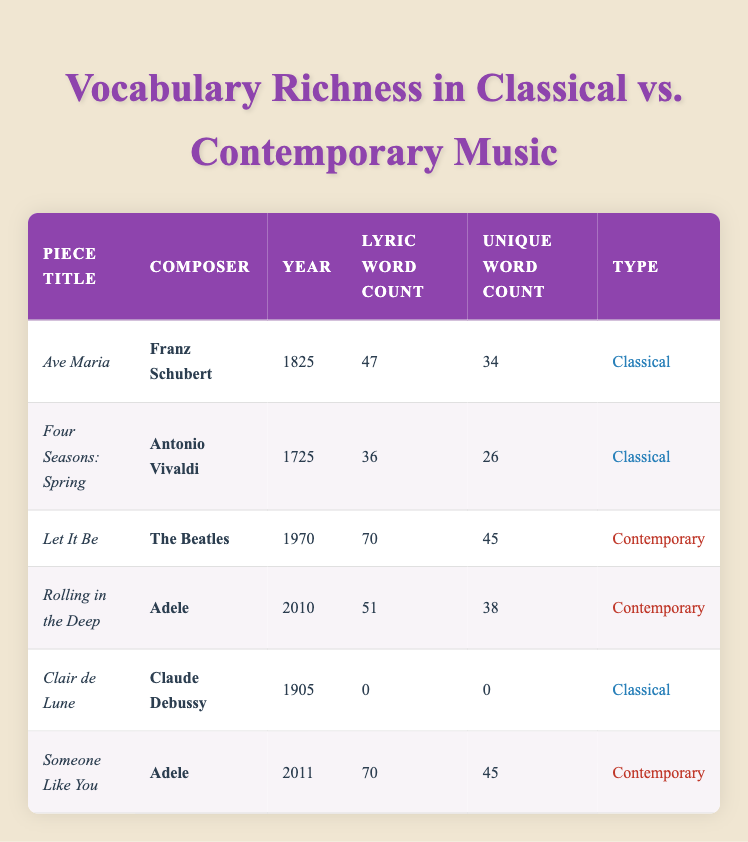What is the unique word count for "Let It Be"? In the table, the row for "Let It Be" lists its unique word count as 45.
Answer: 45 How many lyric words does "Rolling in the Deep" have? The row for "Rolling in the Deep" indicates that it has 51 lyric words in total.
Answer: 51 Which piece has the highest unique word count among contemporary pieces? The contemporary pieces are "Let It Be," "Rolling in the Deep," and "Someone Like You." Their unique word counts are 45, 38, and 45 respectively. "Let It Be" has the highest unique word count of 45.
Answer: 45 What is the total lyric word count for all classical pieces listed? The classical pieces are "Ave Maria" (47), "Four Seasons: Spring" (36), and "Clair de Lune" (0). Adding these together: 47 + 36 + 0 = 83.
Answer: 83 Is it true that "Clair de Lune" has any lyric words? Referring to the table, "Clair de Lune" has a lyric word count of 0, meaning it does not contain any lyric words.
Answer: Yes 